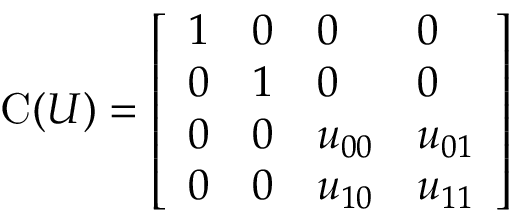<formula> <loc_0><loc_0><loc_500><loc_500>{ C } ( U ) = { \left [ \begin{array} { l l l l } { 1 } & { 0 } & { 0 } & { 0 } \\ { 0 } & { 1 } & { 0 } & { 0 } \\ { 0 } & { 0 } & { u _ { 0 0 } } & { u _ { 0 1 } } \\ { 0 } & { 0 } & { u _ { 1 0 } } & { u _ { 1 1 } } \end{array} \right ] }</formula> 